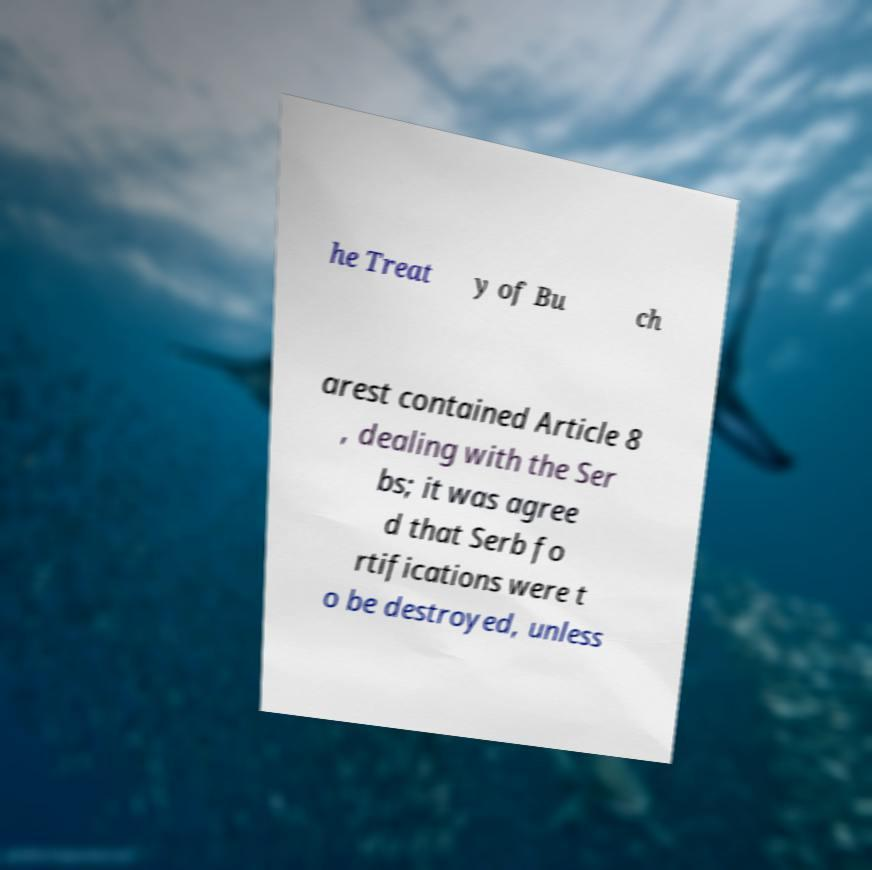For documentation purposes, I need the text within this image transcribed. Could you provide that? he Treat y of Bu ch arest contained Article 8 , dealing with the Ser bs; it was agree d that Serb fo rtifications were t o be destroyed, unless 